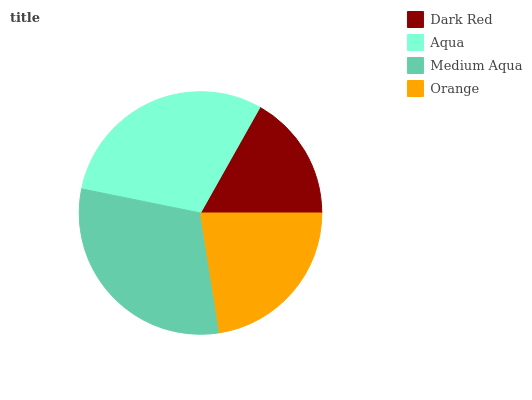Is Dark Red the minimum?
Answer yes or no. Yes. Is Medium Aqua the maximum?
Answer yes or no. Yes. Is Aqua the minimum?
Answer yes or no. No. Is Aqua the maximum?
Answer yes or no. No. Is Aqua greater than Dark Red?
Answer yes or no. Yes. Is Dark Red less than Aqua?
Answer yes or no. Yes. Is Dark Red greater than Aqua?
Answer yes or no. No. Is Aqua less than Dark Red?
Answer yes or no. No. Is Aqua the high median?
Answer yes or no. Yes. Is Orange the low median?
Answer yes or no. Yes. Is Orange the high median?
Answer yes or no. No. Is Aqua the low median?
Answer yes or no. No. 